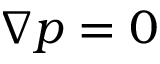Convert formula to latex. <formula><loc_0><loc_0><loc_500><loc_500>\nabla p = 0</formula> 